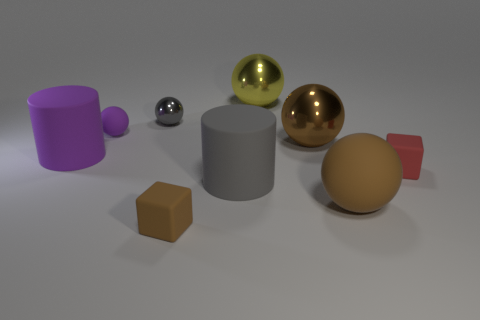What is the size of the yellow metallic sphere?
Provide a short and direct response. Large. What is the shape of the large gray object that is made of the same material as the brown block?
Your answer should be compact. Cylinder. Is the number of small balls left of the yellow ball less than the number of purple cylinders?
Your answer should be compact. No. What is the color of the tiny object that is on the left side of the tiny gray metal object?
Offer a terse response. Purple. There is a small thing that is the same color as the big rubber sphere; what is it made of?
Your answer should be very brief. Rubber. Are there any purple objects of the same shape as the red rubber thing?
Provide a succinct answer. No. How many blue metallic objects are the same shape as the small gray shiny object?
Make the answer very short. 0. Is the color of the small matte sphere the same as the tiny metal thing?
Offer a terse response. No. Are there fewer matte blocks than big yellow things?
Ensure brevity in your answer.  No. What material is the large cylinder on the right side of the small gray ball?
Offer a terse response. Rubber. 